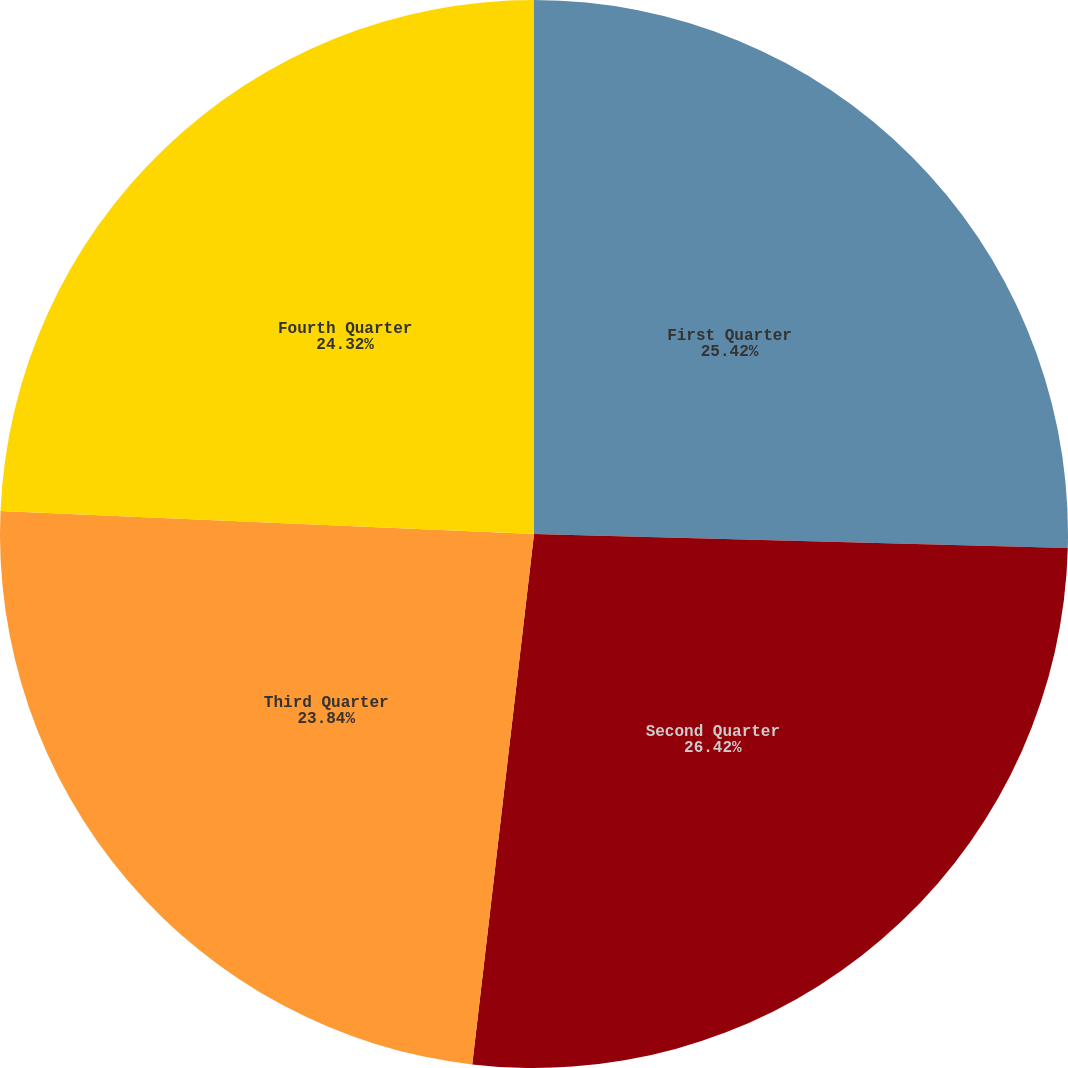Convert chart to OTSL. <chart><loc_0><loc_0><loc_500><loc_500><pie_chart><fcel>First Quarter<fcel>Second Quarter<fcel>Third Quarter<fcel>Fourth Quarter<nl><fcel>25.42%<fcel>26.43%<fcel>23.84%<fcel>24.32%<nl></chart> 